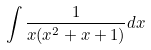<formula> <loc_0><loc_0><loc_500><loc_500>\int \frac { 1 } { x ( x ^ { 2 } + x + 1 ) } d x</formula> 